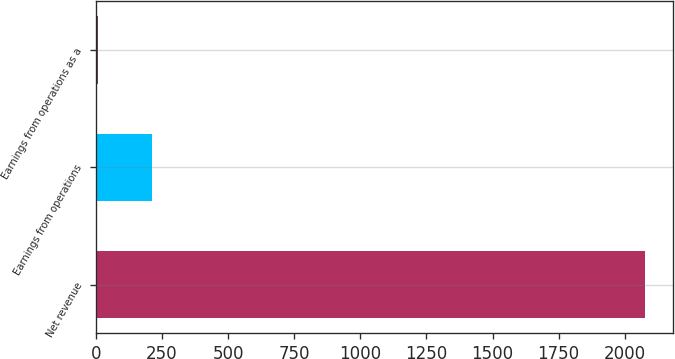Convert chart to OTSL. <chart><loc_0><loc_0><loc_500><loc_500><bar_chart><fcel>Net revenue<fcel>Earnings from operations<fcel>Earnings from operations as a<nl><fcel>2078<fcel>214.19<fcel>7.1<nl></chart> 